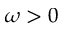<formula> <loc_0><loc_0><loc_500><loc_500>\omega > 0</formula> 